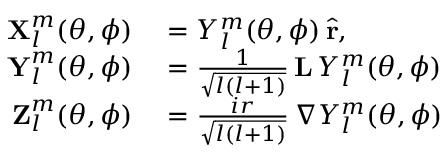Convert formula to latex. <formula><loc_0><loc_0><loc_500><loc_500>\begin{array} { r l } { X _ { l } ^ { m } ( \theta , \phi ) } & = Y _ { l } ^ { m } ( \theta , \phi ) \, \hat { r } , } \\ { Y _ { l } ^ { m } ( \theta , \phi ) } & = \frac { 1 } { \sqrt { l ( l + 1 ) } } \, L \, Y _ { l } ^ { m } ( \theta , \phi ) } \\ { Z _ { l } ^ { m } ( \theta , \phi ) } & = \frac { i r } { \sqrt { l ( l + 1 ) } } \, \nabla Y _ { l } ^ { m } ( \theta , \phi ) } \end{array}</formula> 